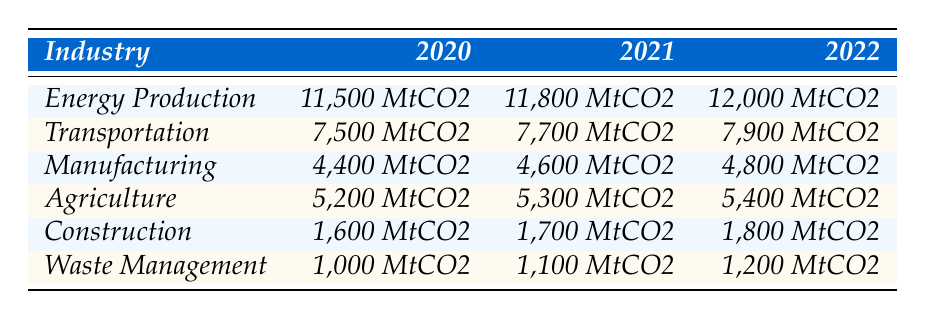What was the carbon footprint of the Energy Production industry in 2021? From the table, the Energy Production industry had a carbon footprint of 11,800 MtCO2 in 2021.
Answer: 11,800 MtCO2 Which industry had the lowest carbon footprint in 2020? The table shows that Waste Management had the lowest carbon footprint of 1,000 MtCO2 in 2020.
Answer: Waste Management What is the difference in carbon footprint for Agriculture from 2020 to 2022? The carbon footprint for Agriculture in 2020 was 5,200 MtCO2 and in 2022 it was 5,400 MtCO2. The difference is 5,400 - 5,200 = 200 MtCO2.
Answer: 200 MtCO2 What was the average carbon footprint of the Transportation industry over these three years? The carbon footprint for Transportation is 7,500 MtCO2 (2020), 7,700 MtCO2 (2021), and 7,900 MtCO2 (2022). The average is (7,500 + 7,700 + 7,900) / 3 = 7,700 MtCO2.
Answer: 7,700 MtCO2 Did the Manufacturing industry's carbon footprint increase every year from 2020 to 2022? The table shows that the Manufacturing industry's carbon footprints were 4,400 MtCO2 (2020), 4,600 MtCO2 (2021), and 4,800 MtCO2 (2022), indicating a steady increase each year.
Answer: Yes In total, what was the carbon footprint of all industries combined in 2022? The carbon footprints for each industry in 2022 are: Energy Production (12,000 MtCO2), Transportation (7,900 MtCO2), Manufacturing (4,800 MtCO2), Agriculture (5,400 MtCO2), Construction (1,800 MtCO2), and Waste Management (1,200 MtCO2). Adding these gives 12,000 + 7,900 + 4,800 + 5,400 + 1,800 + 1,200 = 33,100 MtCO2.
Answer: 33,100 MtCO2 Which industry saw the most significant absolute increase in carbon footprint from 2020 to 2022? By looking at the increases: Energy Production increased by 500 MtCO2, Transportation by 400 MtCO2, Manufacturing by 400 MtCO2, Agriculture by 200 MtCO2, Construction by 200 MtCO2, and Waste Management by 200 MtCO2. Energy Production had the highest increase of 500 MtCO2.
Answer: Energy Production What is the total carbon footprint of the Construction and Waste Management industries in 2021? In 2021, the carbon footprint for Construction was 1,700 MtCO2 and for Waste Management was 1,100 MtCO2. Adding these gives 1,700 + 1,100 = 2,800 MtCO2.
Answer: 2,800 MtCO2 